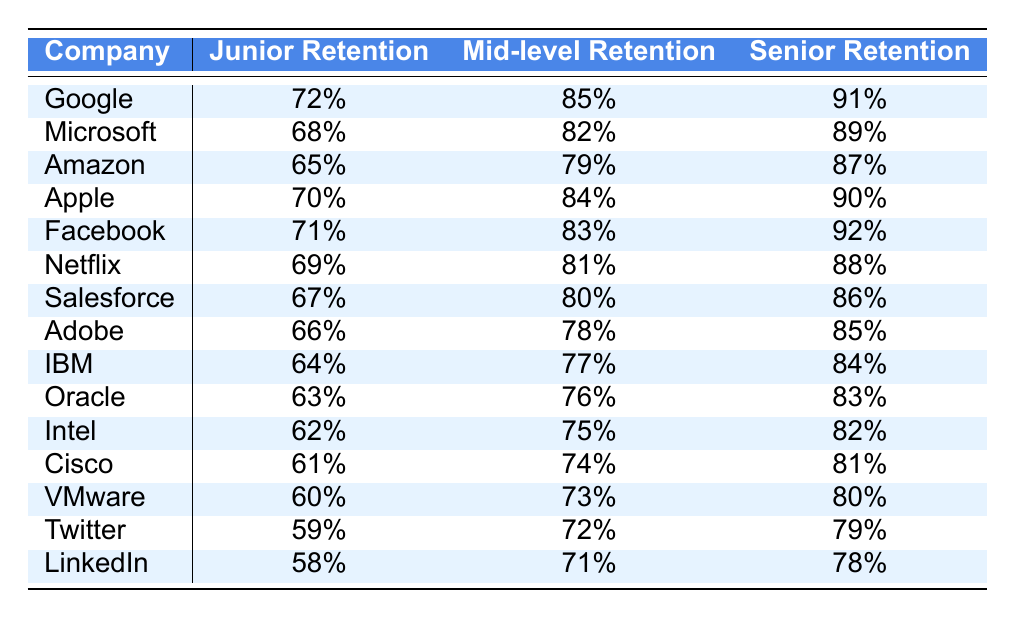What is the Junior Retention rate for Google? Referring to the table, the Junior Retention rate listed for Google is 72%.
Answer: 72% Which company has the highest Senior Retention rate? By examining the Senior Retention rates, Facebook has the highest value at 92%.
Answer: Facebook What is the difference in Mid-level Retention rate between Google and Microsoft? The Mid-level Retention for Google is 85%, and for Microsoft, it is 82%. The difference is calculated as 85% - 82% = 3%.
Answer: 3% What is the average Junior Retention rate across all companies listed? To find the average, sum up the Junior Retention rates (72 + 68 + 65 + 70 + 71 + 69 + 67 + 66 + 64 + 63 + 62 + 61 + 60 + 59 + 58 = 1048) and divide by the number of companies (15). So the average is 1048 / 15 = approximately 69.87%.
Answer: 69.87% Is Facebook's Junior Retention rate greater than Amazon's? The Junior Retention rate for Facebook is 71%, while for Amazon, it is 65%. Since 71% is greater than 65%, the statement is true.
Answer: Yes Which company has the lowest Mid-level Retention rate? By checking the Mid-level Retention rates, LinkedIn shows the lowest at 71%.
Answer: LinkedIn What is the sum of the Senior Retention rates for IBM and Oracle? For IBM, the Senior Retention rate is 84% and for Oracle, it is 83%. Adding these values gives 84% + 83% = 167%.
Answer: 167% How many companies have a Junior Retention rate above 70%? By checking each Junior Retention rate, the companies with rates above 70% are Google, Apple, Facebook, and Amazon (4 companies).
Answer: 4 What is the median Mid-level Retention rate among the companies listed? By arranging the Mid-level Retention rates in ascending order (71, 72, 73, 74, 75, 76, 77, 78, 79, 80, 81, 82, 83, 84, 85), the median (middle value of the 15 numbers) is the 8th value, which is 80%.
Answer: 80% Is the average Senior Retention rate higher than 85%? The total of Senior Retention rates is (91 + 89 + 87 + 90 + 92 + 88 + 86 + 85 + 84 + 83 + 82 + 81 + 80 + 79 + 78 = 1303). Dividing by 15 gives 1303 / 15 ≈ 86.87%, which is greater than 85%.
Answer: Yes 